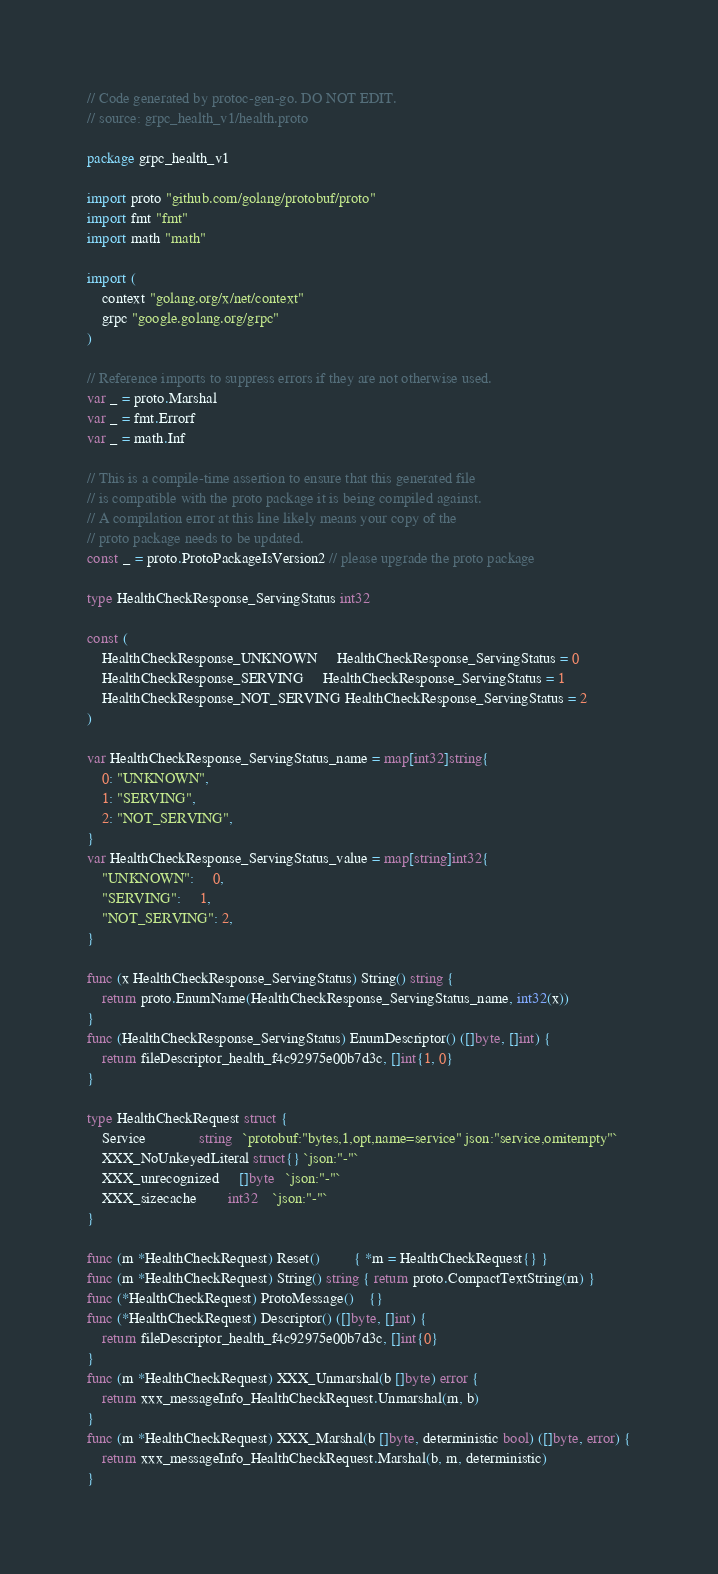<code> <loc_0><loc_0><loc_500><loc_500><_Go_>// Code generated by protoc-gen-go. DO NOT EDIT.
// source: grpc_health_v1/health.proto

package grpc_health_v1

import proto "github.com/golang/protobuf/proto"
import fmt "fmt"
import math "math"

import (
	context "golang.org/x/net/context"
	grpc "google.golang.org/grpc"
)

// Reference imports to suppress errors if they are not otherwise used.
var _ = proto.Marshal
var _ = fmt.Errorf
var _ = math.Inf

// This is a compile-time assertion to ensure that this generated file
// is compatible with the proto package it is being compiled against.
// A compilation error at this line likely means your copy of the
// proto package needs to be updated.
const _ = proto.ProtoPackageIsVersion2 // please upgrade the proto package

type HealthCheckResponse_ServingStatus int32

const (
	HealthCheckResponse_UNKNOWN     HealthCheckResponse_ServingStatus = 0
	HealthCheckResponse_SERVING     HealthCheckResponse_ServingStatus = 1
	HealthCheckResponse_NOT_SERVING HealthCheckResponse_ServingStatus = 2
)

var HealthCheckResponse_ServingStatus_name = map[int32]string{
	0: "UNKNOWN",
	1: "SERVING",
	2: "NOT_SERVING",
}
var HealthCheckResponse_ServingStatus_value = map[string]int32{
	"UNKNOWN":     0,
	"SERVING":     1,
	"NOT_SERVING": 2,
}

func (x HealthCheckResponse_ServingStatus) String() string {
	return proto.EnumName(HealthCheckResponse_ServingStatus_name, int32(x))
}
func (HealthCheckResponse_ServingStatus) EnumDescriptor() ([]byte, []int) {
	return fileDescriptor_health_f4c92975e00b7d3c, []int{1, 0}
}

type HealthCheckRequest struct {
	Service              string   `protobuf:"bytes,1,opt,name=service" json:"service,omitempty"`
	XXX_NoUnkeyedLiteral struct{} `json:"-"`
	XXX_unrecognized     []byte   `json:"-"`
	XXX_sizecache        int32    `json:"-"`
}

func (m *HealthCheckRequest) Reset()         { *m = HealthCheckRequest{} }
func (m *HealthCheckRequest) String() string { return proto.CompactTextString(m) }
func (*HealthCheckRequest) ProtoMessage()    {}
func (*HealthCheckRequest) Descriptor() ([]byte, []int) {
	return fileDescriptor_health_f4c92975e00b7d3c, []int{0}
}
func (m *HealthCheckRequest) XXX_Unmarshal(b []byte) error {
	return xxx_messageInfo_HealthCheckRequest.Unmarshal(m, b)
}
func (m *HealthCheckRequest) XXX_Marshal(b []byte, deterministic bool) ([]byte, error) {
	return xxx_messageInfo_HealthCheckRequest.Marshal(b, m, deterministic)
}</code> 